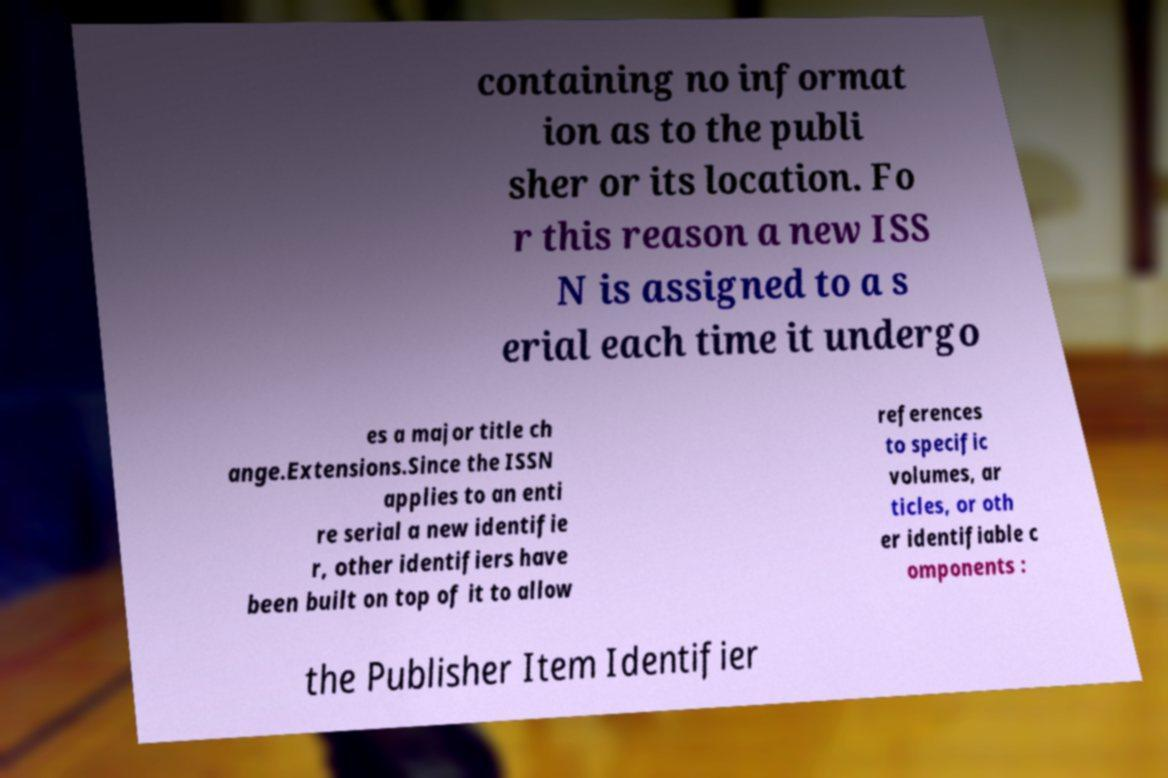Can you accurately transcribe the text from the provided image for me? containing no informat ion as to the publi sher or its location. Fo r this reason a new ISS N is assigned to a s erial each time it undergo es a major title ch ange.Extensions.Since the ISSN applies to an enti re serial a new identifie r, other identifiers have been built on top of it to allow references to specific volumes, ar ticles, or oth er identifiable c omponents : the Publisher Item Identifier 